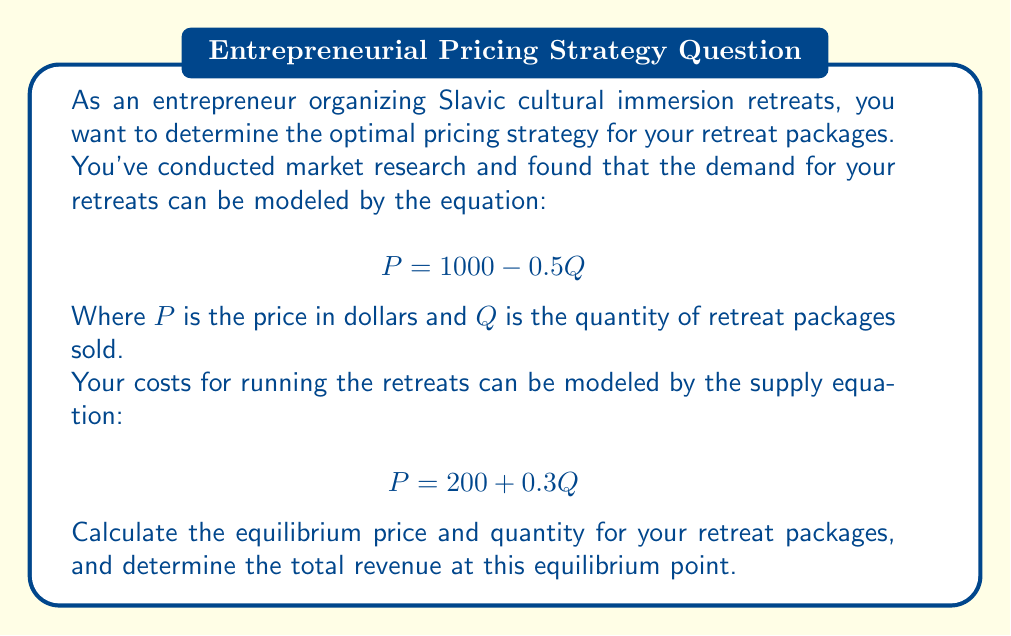Teach me how to tackle this problem. To solve this problem, we need to follow these steps:

1. Find the equilibrium point by setting the demand and supply equations equal to each other:

   $$1000 - 0.5Q = 200 + 0.3Q$$

2. Solve for Q:

   $$800 = 0.8Q$$
   $$Q = 1000$$

3. Find the equilibrium price by substituting Q = 1000 into either the demand or supply equation. Let's use the demand equation:

   $$P = 1000 - 0.5(1000) = 500$$

4. Calculate the total revenue at the equilibrium point:

   $$\text{Total Revenue} = P \times Q = 500 \times 1000 = 500,000$$

Therefore, the equilibrium price is $500, the equilibrium quantity is 1000 retreat packages, and the total revenue at this point is $500,000.
Answer: Equilibrium price: $500
Equilibrium quantity: 1000 retreat packages
Total revenue at equilibrium: $500,000 